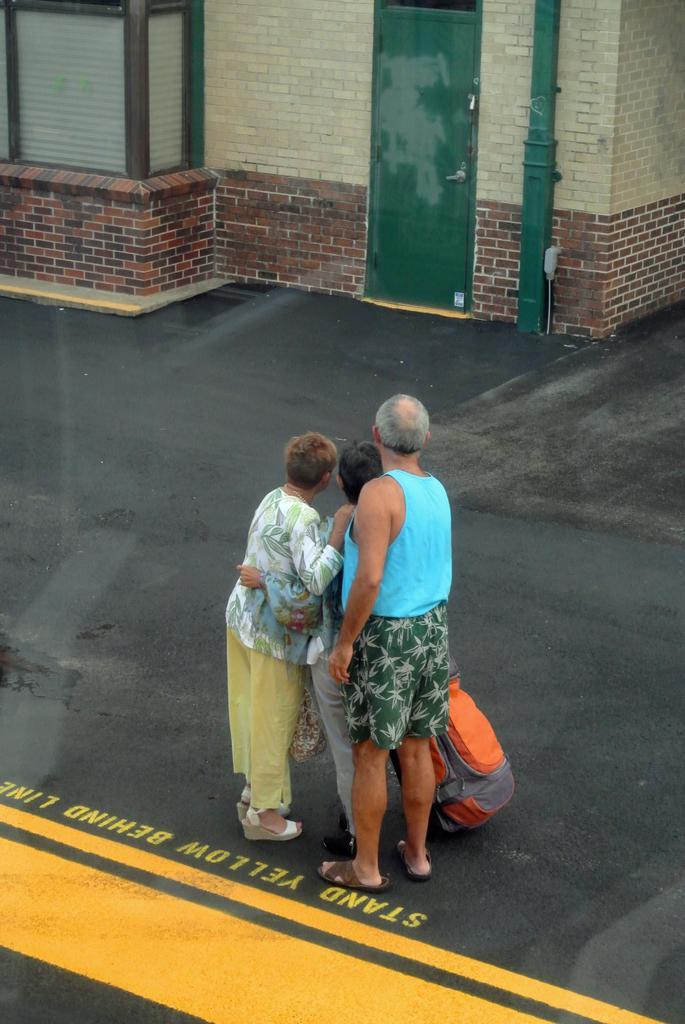Please provide a concise description of this image. In this picture I can see there are three people standing here and there is a luggage with them and in the backdrop there is a building with a door and a brick wall. 